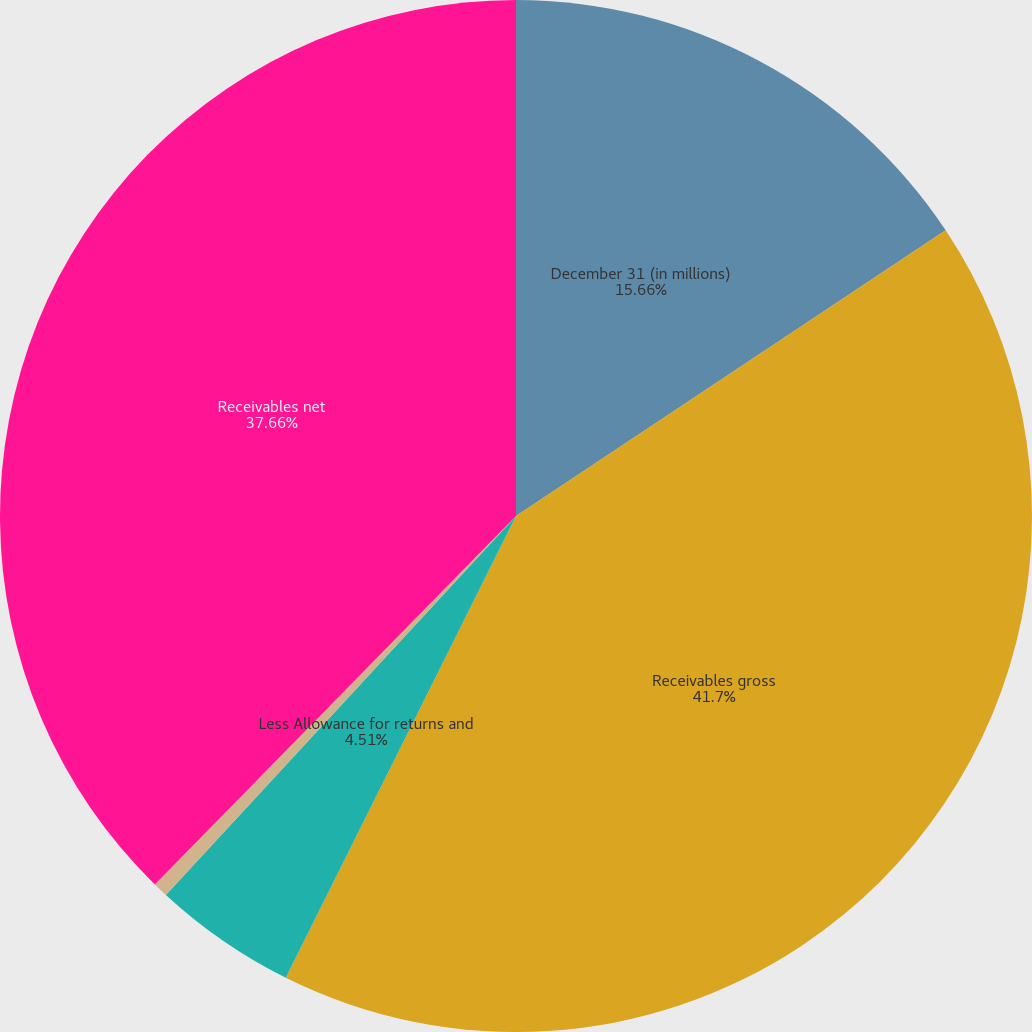Convert chart to OTSL. <chart><loc_0><loc_0><loc_500><loc_500><pie_chart><fcel>December 31 (in millions)<fcel>Receivables gross<fcel>Less Allowance for returns and<fcel>Less Allowance for doubtful<fcel>Receivables net<nl><fcel>15.66%<fcel>41.7%<fcel>4.51%<fcel>0.47%<fcel>37.66%<nl></chart> 